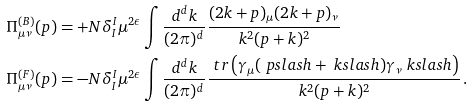<formula> <loc_0><loc_0><loc_500><loc_500>\Pi _ { \mu \nu } ^ { ( B ) } ( p ) & = + N \delta ^ { I } _ { I } \mu ^ { 2 \epsilon } \int \frac { d ^ { d } k } { ( 2 \pi ) ^ { d } } \frac { ( 2 k + p ) _ { \mu } ( 2 k + p ) _ { \nu } } { k ^ { 2 } ( p + k ) ^ { 2 } } \\ \Pi _ { \mu \nu } ^ { ( F ) } ( p ) & = - N \delta ^ { I } _ { I } \mu ^ { 2 \epsilon } \int \frac { d ^ { d } k } { ( 2 \pi ) ^ { d } } \frac { \ t r \left ( \gamma _ { \mu } ( \ p s l a s h + \ k s l a s h ) \gamma _ { \nu } \ k s l a s h \right ) } { k ^ { 2 } ( p + k ) ^ { 2 } } \, .</formula> 